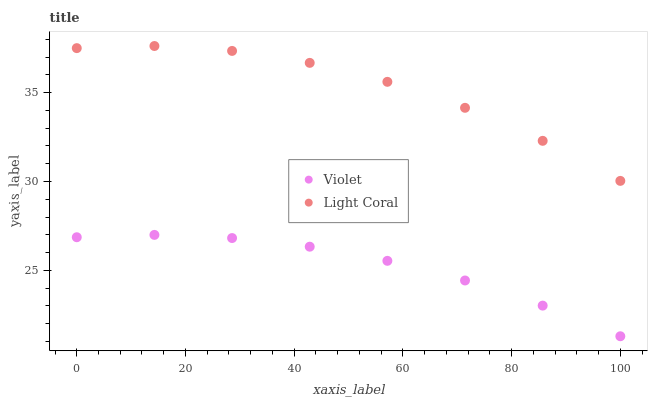Does Violet have the minimum area under the curve?
Answer yes or no. Yes. Does Light Coral have the maximum area under the curve?
Answer yes or no. Yes. Does Violet have the maximum area under the curve?
Answer yes or no. No. Is Violet the smoothest?
Answer yes or no. Yes. Is Light Coral the roughest?
Answer yes or no. Yes. Is Violet the roughest?
Answer yes or no. No. Does Violet have the lowest value?
Answer yes or no. Yes. Does Light Coral have the highest value?
Answer yes or no. Yes. Does Violet have the highest value?
Answer yes or no. No. Is Violet less than Light Coral?
Answer yes or no. Yes. Is Light Coral greater than Violet?
Answer yes or no. Yes. Does Violet intersect Light Coral?
Answer yes or no. No. 